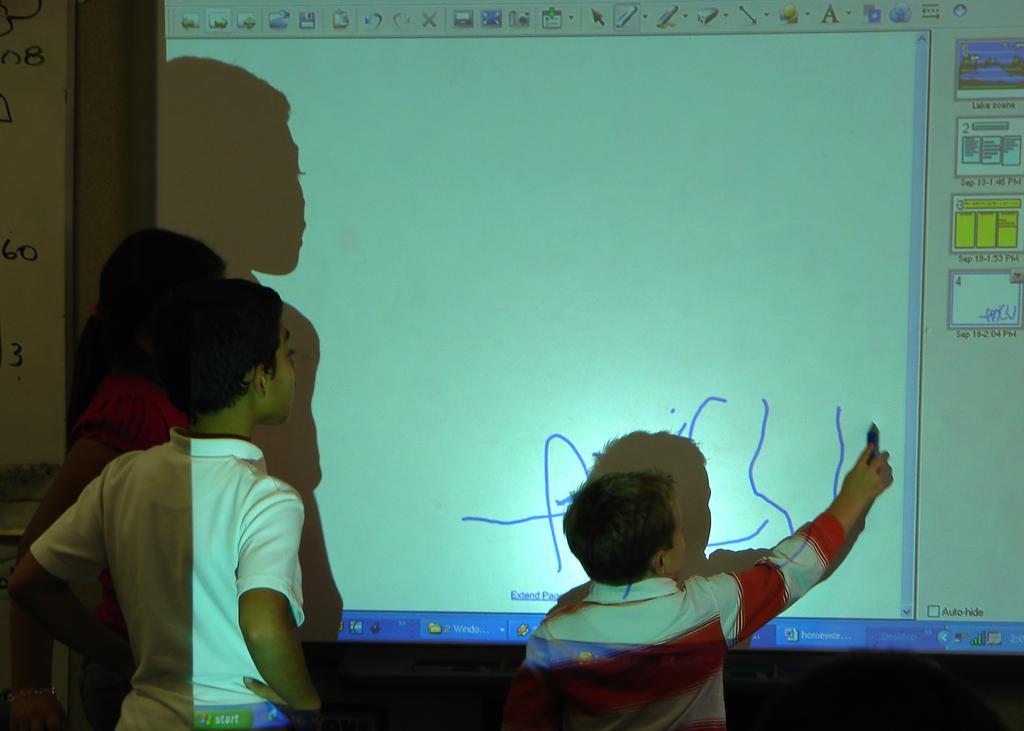Describe this image in one or two sentences. In this image, there are three persons standing. Among them one person is writing. In front of three persons, I can a projector screen. On the left side of the image, I can see a white board to the wall. 